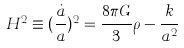<formula> <loc_0><loc_0><loc_500><loc_500>H ^ { 2 } \equiv ( \frac { \dot { a } } { a } ) ^ { 2 } = \frac { 8 \pi G } { 3 } \rho - \frac { k } { a ^ { 2 } }</formula> 